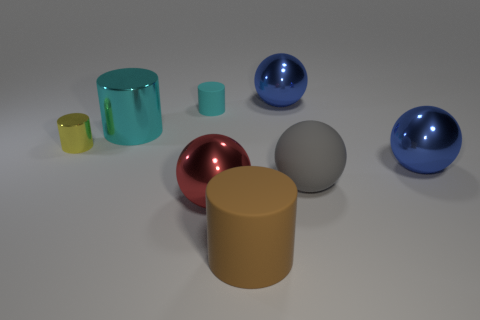Subtract all brown cylinders. How many cylinders are left? 3 Subtract all big rubber cylinders. How many cylinders are left? 3 Subtract all green balls. Subtract all brown cylinders. How many balls are left? 4 Add 1 large cyan objects. How many objects exist? 9 Add 5 small rubber cylinders. How many small rubber cylinders exist? 6 Subtract 0 green cylinders. How many objects are left? 8 Subtract all big cylinders. Subtract all cyan metal cylinders. How many objects are left? 5 Add 1 small objects. How many small objects are left? 3 